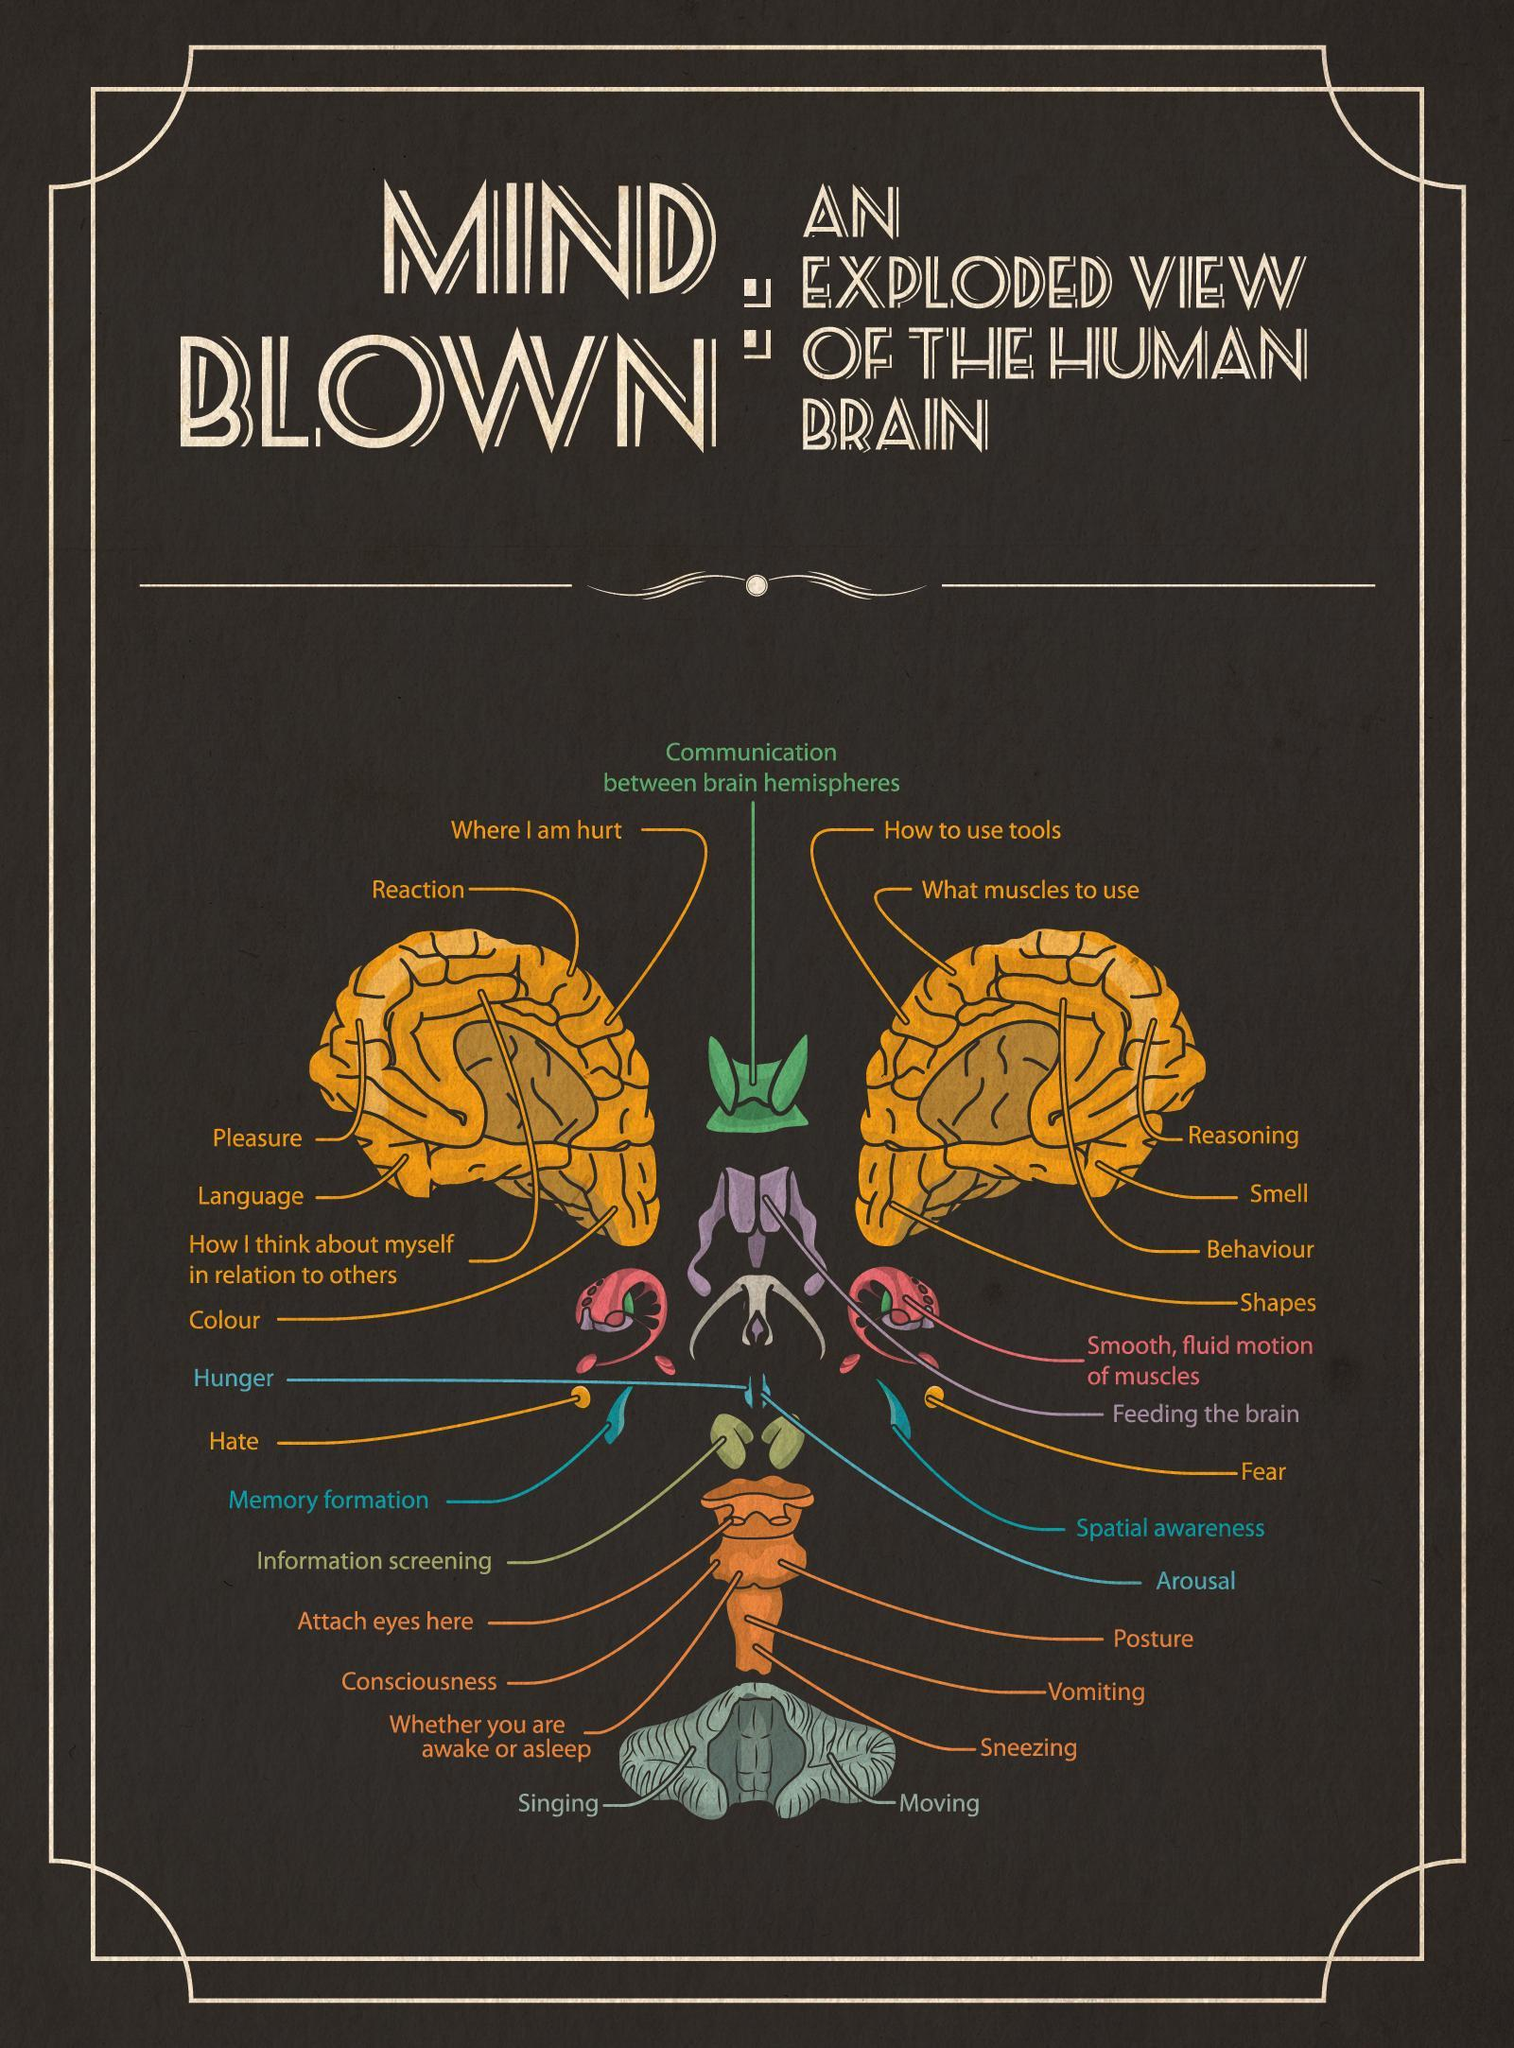How many items are marked in the picture?
Answer the question with a short phrase. 30 The part of the brain called "Reaction" is marked in which of the color- pink, yellow, violet, green? yellow 